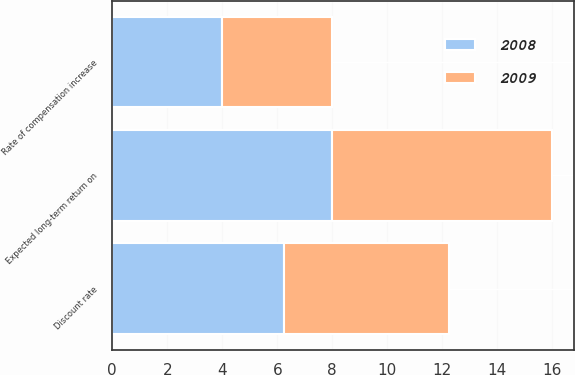Convert chart. <chart><loc_0><loc_0><loc_500><loc_500><stacked_bar_chart><ecel><fcel>Discount rate<fcel>Expected long-term return on<fcel>Rate of compensation increase<nl><fcel>2008<fcel>6.25<fcel>8<fcel>4<nl><fcel>2009<fcel>6<fcel>8<fcel>4<nl></chart> 